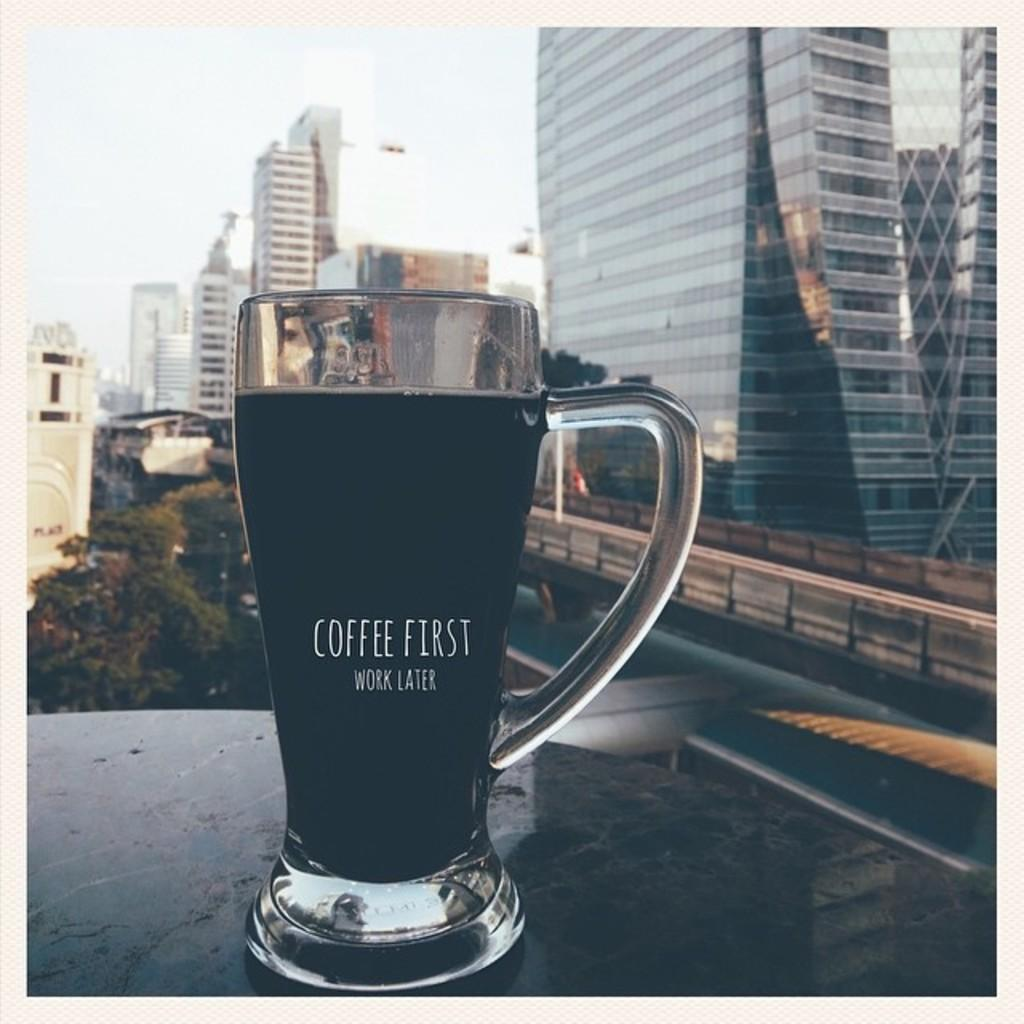<image>
Summarize the visual content of the image. A cup of coffee that says coffee first work later in front of several buildings. 